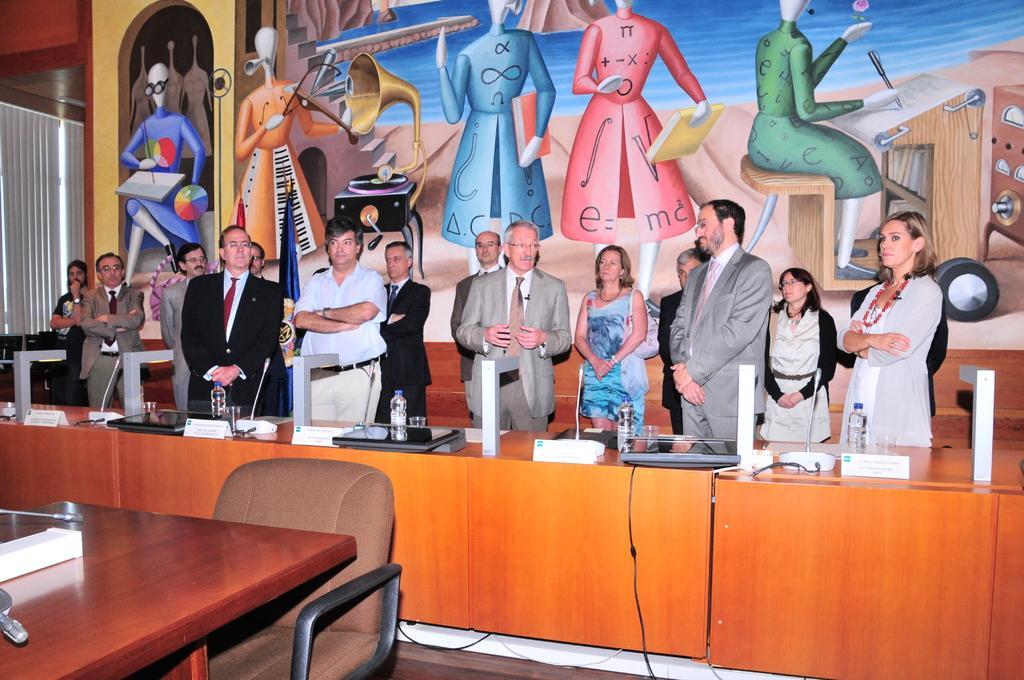Describe this image in one or two sentences. In this picture we can see group of people standing and in middle person is talking and in front of them there is table and on table we can see bottle, name board, laptops, glass, mic and here it is chair and in background we can see wall with paintings. 